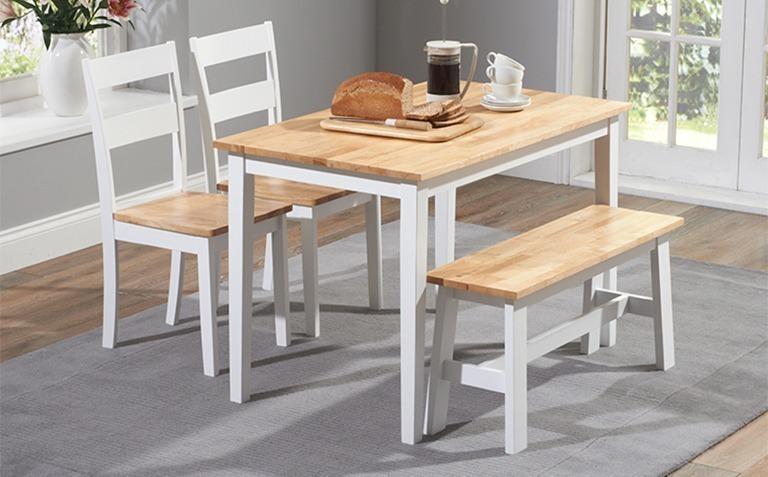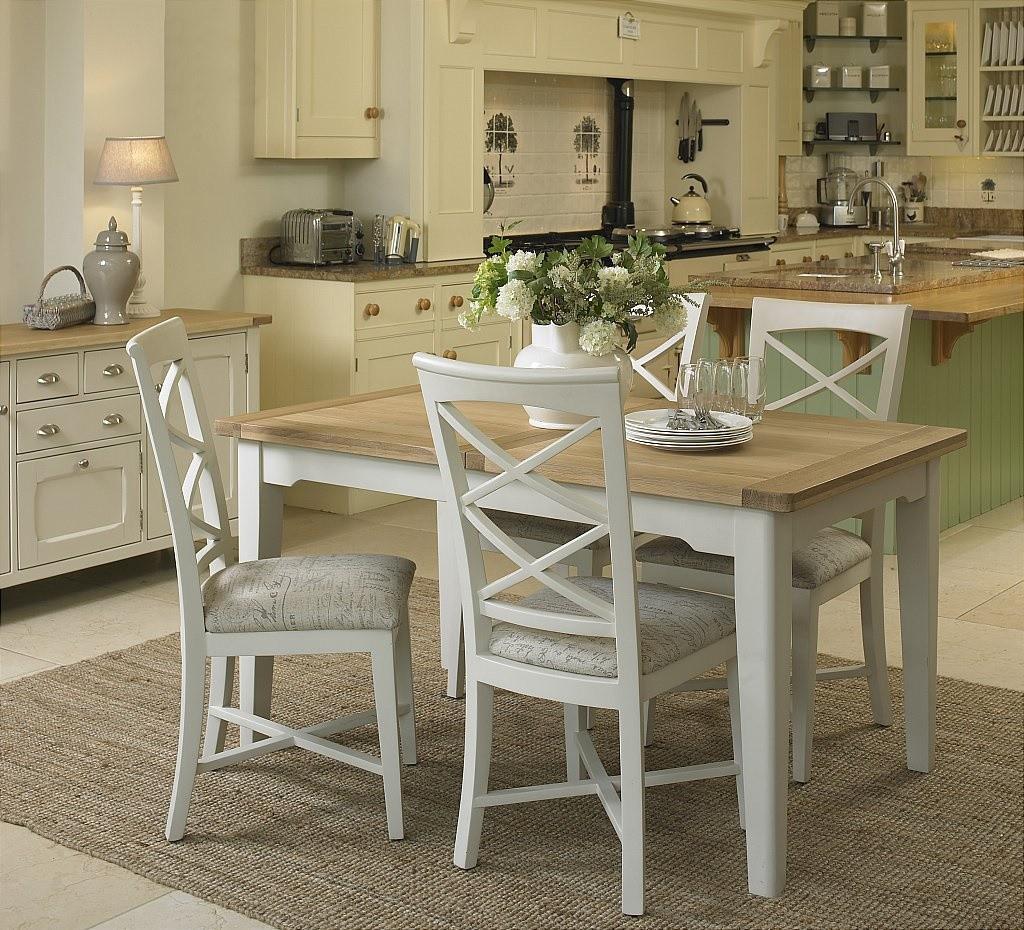The first image is the image on the left, the second image is the image on the right. Considering the images on both sides, is "A dining table in one image is round with four chairs, while a table in the second image is elongated and has six chairs." valid? Answer yes or no. No. The first image is the image on the left, the second image is the image on the right. Assess this claim about the two images: "One image shows white chairs around a round pedestal table, and the other shows white chairs around an oblong pedestal table.". Correct or not? Answer yes or no. No. 